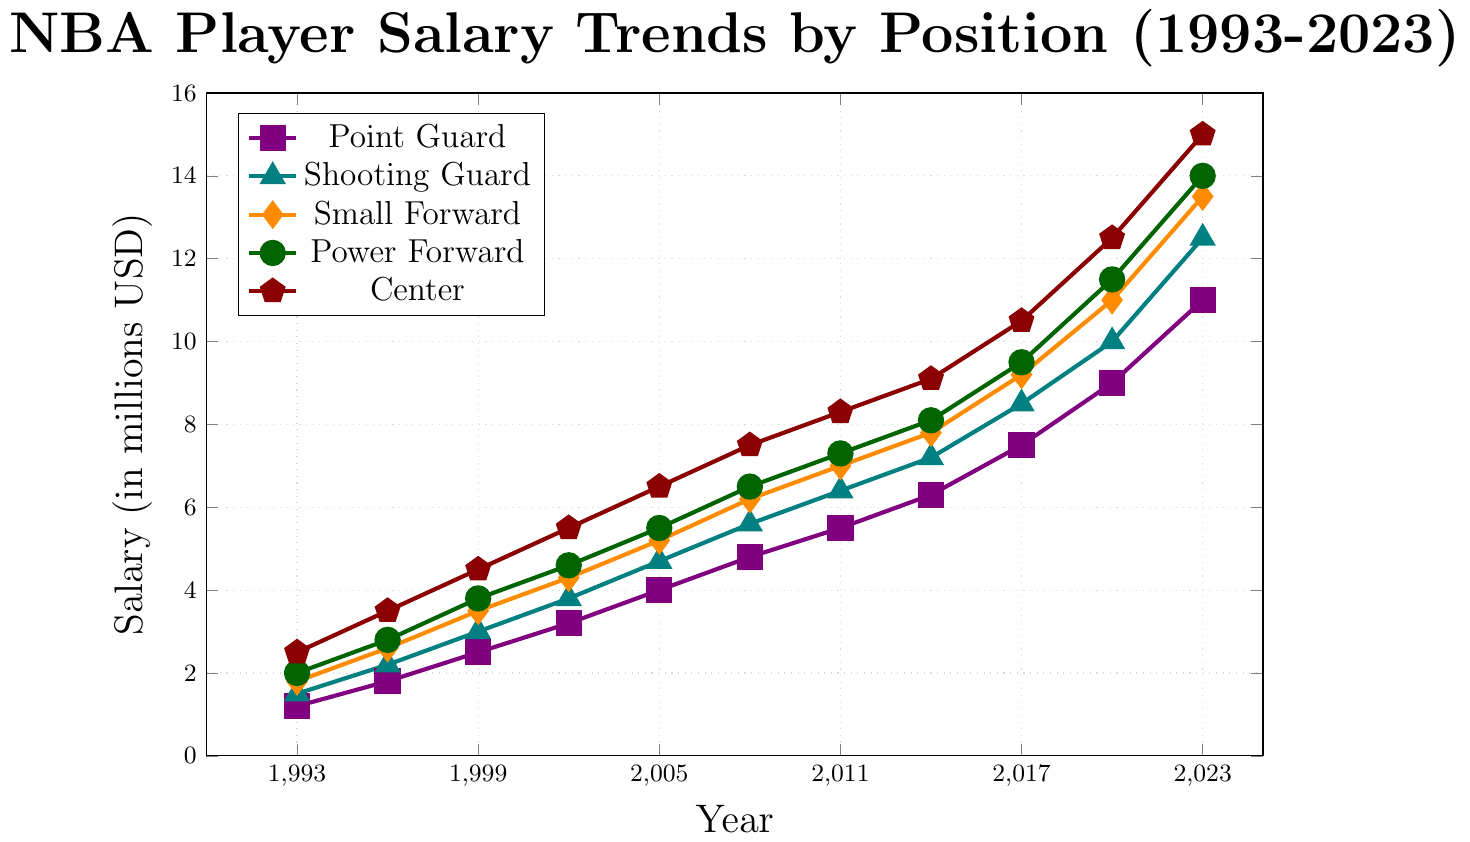What is the salary difference between Centers and Point Guards in 2023? Look at the salary for Centers in 2023, which is $15M, and the salary for Point Guards in 2023, which is $11M. Subtract the Point Guard salary from the Center salary: $15M - $11M.
Answer: $4M How has the salary for Shooting Guards changed from 1993 to 2023? Look at the salary for Shooting Guards in 1993, which is $1.5M, and the salary in 2023, which is $12.5M. Subtract the 1993 salary from the 2023 salary: $12.5M - $1.5M.
Answer: $11M Which position had the highest salary increase between 1993 and 2023? Calculate the difference in salary for each position between 1993 and 2023. For Point Guard: $11M - $1.2M = $9.8M. For Shooting Guard: $12.5M - $1.5M = $11M. For Small Forward: $13.5M - $1.8M = $11.7M. For Power Forward: $14M - $2M = $12M. For Center: $15M - $2.5M = $12.5M. Compare these values.
Answer: Center What is the average salary of Power Forwards from 1993 to 2023? Add the Power Forward salaries from each year and divide by the number of years: (2 + 2.8 + 3.8 + 4.6 + 5.5 + 6.5 + 7.3 + 8.1 + 9.5 + 11.5 + 14)M / 11.
Answer: $6.745M Between which two consecutive years did Small Forwards see the highest salary increase? Calculate the salary increase for Small Forwards between each consecutive year: 
1993-1996: $2.6M - $1.8M = $0.8M,
1996-1999: $3.5M - $2.6M = $0.9M,
1999-2002: $4.3M - $3.5M = $0.8M,
2002-2005: $5.2M - $4.3M = $0.9M,
2005-2008: $6.2M - $5.2M = $1M,
2008-2011: $7M - $6.2M = $0.8M,
2011-2014: $7.8M - $7M = $0.8M,
2014-2017: $9.2M - $7.8M = $1.4M,
2017-2020: $11M - $9.2M = $1.8M,
2020-2023: $13.5M - $11M = $2.5M.
Compare these values.
Answer: 2020-2023 In which year did Point Guards see a salary of $4 million? Look at the plot for Point Guards and identify the year where the salary is $4 million.
Answer: 2005 What was the salary ratio between Small Forwards and Centers in 1993? Look at the salaries for Small Forwards and Centers in 1993: Small Forward is $1.8M, and Center is $2.5M. Divide the Small Forward salary by the Center salary: $1.8M / $2.5M.
Answer: 0.72 By how much did the salary for Power Forwards increase from 2014 to 2020? Look at the salary for Power Forwards in 2014, which is $8.1M, and in 2020, which is $11.5M. Subtract the 2014 salary from the 2020 salary: $11.5M - $8.1M.
Answer: $3.4M Which position had the smallest salary in 1993, and what was it? Compare the salaries for each position in 1993: Point Guard had $1.2M, Shooting Guard had $1.5M, Small Forward had $1.8M, Power Forward had $2M, and Center had $2.5M. Identify the smallest value.
Answer: Point Guard, $1.2M 